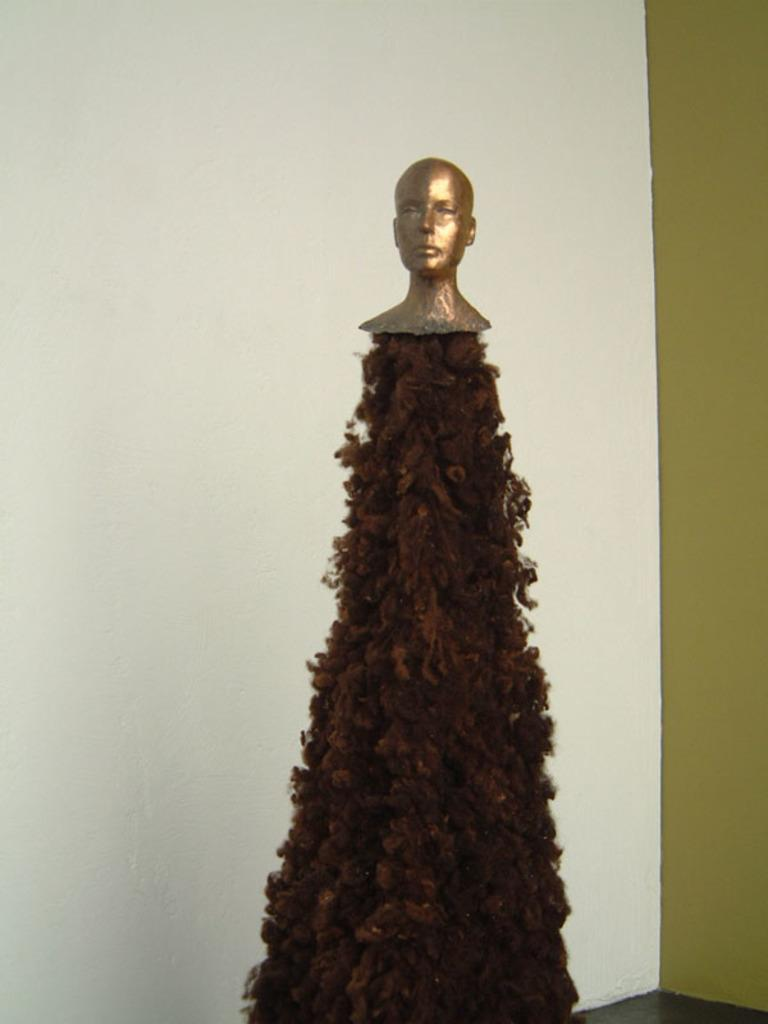What is the main subject in the middle of the image? There is a statue in the middle of the image. What can be seen in the background of the image? There is a wall visible in the background of the image. How many deer are visible near the faucet in the image? There are no deer or faucets present in the image. What type of amusement can be seen in the image? There is no amusement depicted in the image; it features a statue and a wall in the background. 